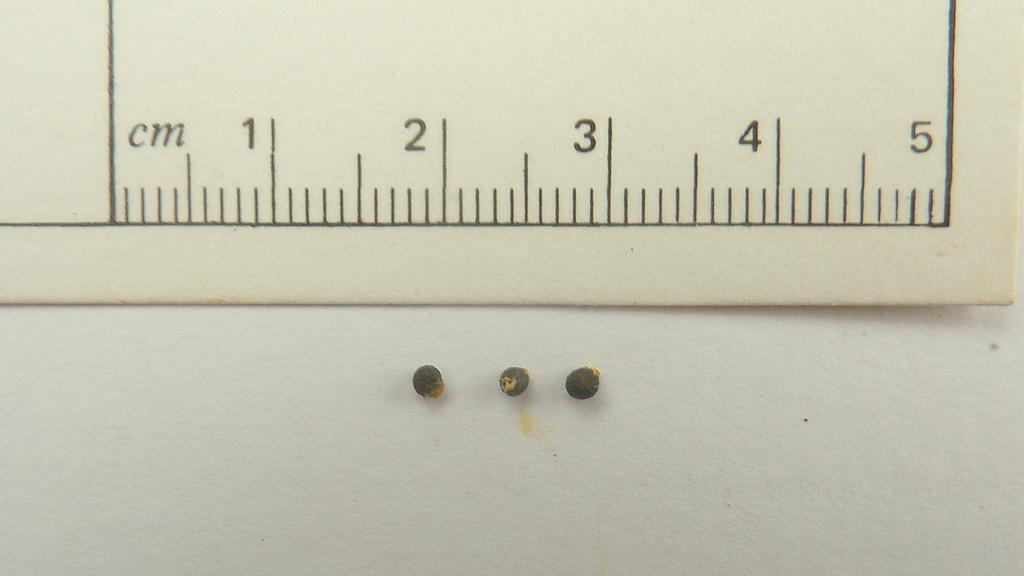What is the length of the ruler?
Your answer should be compact. 5 cm. How many centimeters can this measure?
Ensure brevity in your answer.  5. 